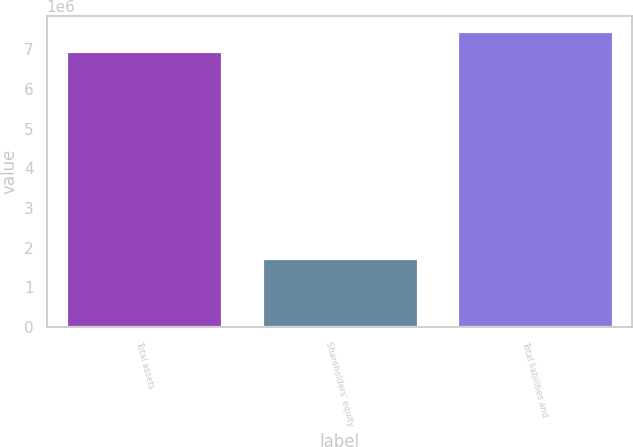Convert chart to OTSL. <chart><loc_0><loc_0><loc_500><loc_500><bar_chart><fcel>Total assets<fcel>Shareholders' equity<fcel>Total liabilities and<nl><fcel>6.94396e+06<fcel>1.73225e+06<fcel>7.46513e+06<nl></chart> 